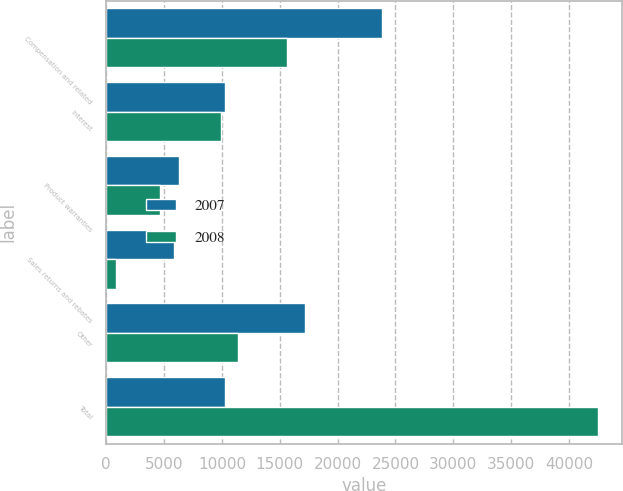Convert chart. <chart><loc_0><loc_0><loc_500><loc_500><stacked_bar_chart><ecel><fcel>Compensation and related<fcel>Interest<fcel>Product warranties<fcel>Sales returns and rebates<fcel>Other<fcel>Total<nl><fcel>2007<fcel>23826<fcel>10266<fcel>6255<fcel>5858<fcel>17157<fcel>10266<nl><fcel>2008<fcel>15651<fcel>9930<fcel>4624<fcel>829<fcel>11432<fcel>42466<nl></chart> 